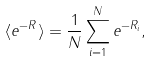<formula> <loc_0><loc_0><loc_500><loc_500>\langle e ^ { - R } \rangle = \frac { 1 } { N } \sum _ { i = 1 } ^ { N } e ^ { - R _ { i } } ,</formula> 